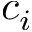<formula> <loc_0><loc_0><loc_500><loc_500>c _ { i }</formula> 